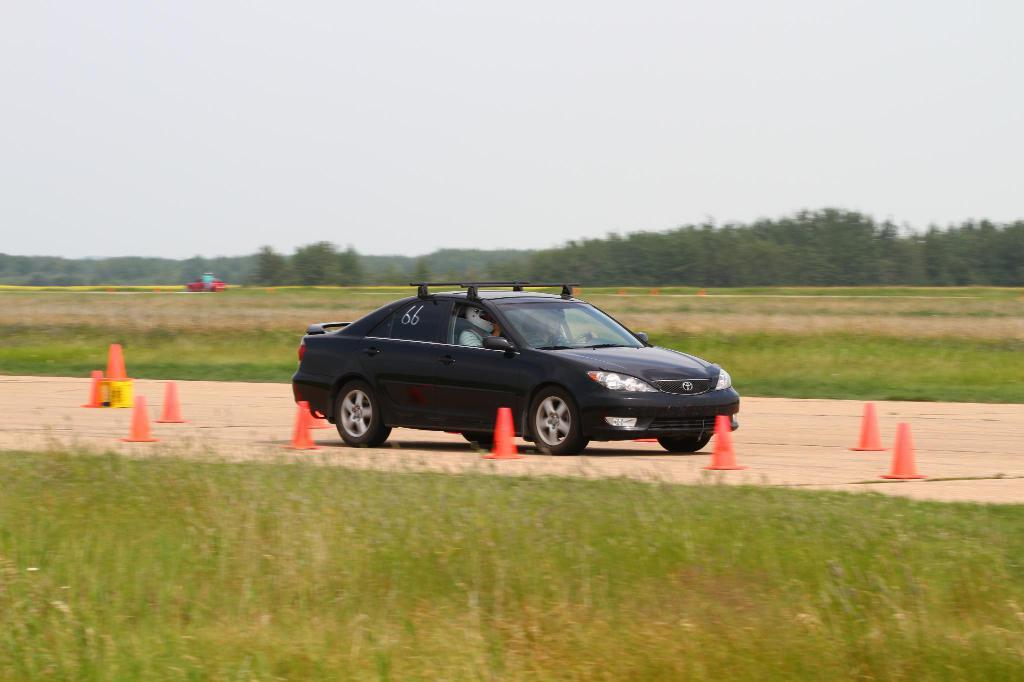What is the main subject of the image? There is a car in the image. What objects are present near the car? Traffic cones are present in the image. What type of terrain is visible in the image? The land appears to be grassy. What can be seen in the background of the image? There are trees and another vehicle in the background of the image. What is visible at the top of the image? The sky is visible at the top of the image. What emotion does the car express towards the trees in the image? Cars do not express emotions, so this question cannot be answered. 